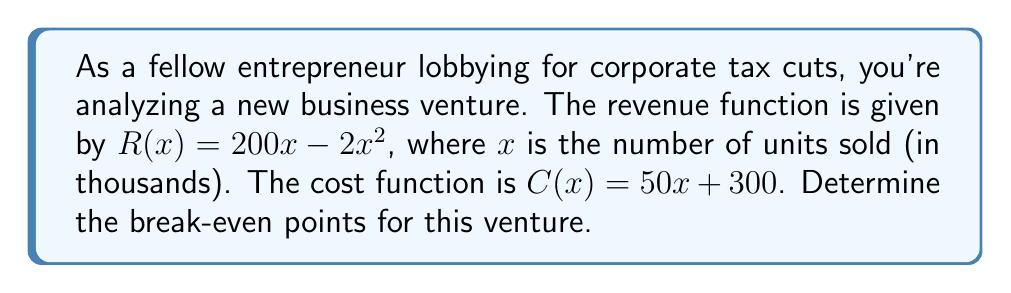Can you solve this math problem? To find the break-even points, we need to solve the equation where revenue equals cost:

1) Set up the equation:
   $R(x) = C(x)$
   $200x - 2x^2 = 50x + 300$

2) Rearrange to standard form:
   $-2x^2 + 150x - 300 = 0$

3) This is a quadratic equation. We can solve it using the quadratic formula:
   $x = \frac{-b \pm \sqrt{b^2 - 4ac}}{2a}$

   Where $a = -2$, $b = 150$, and $c = -300$

4) Substitute these values:
   $x = \frac{-150 \pm \sqrt{150^2 - 4(-2)(-300)}}{2(-2)}$

5) Simplify:
   $x = \frac{-150 \pm \sqrt{22500 - 2400}}{-4}$
   $x = \frac{-150 \pm \sqrt{20100}}{-4}$
   $x = \frac{-150 \pm 141.77}{-4}$

6) Solve for both possibilities:
   $x_1 = \frac{-150 + 141.77}{-4} = 2.06$
   $x_2 = \frac{-150 - 141.77}{-4} = 72.94$

7) Interpret the results:
   The break-even points occur at approximately 2,060 and 72,940 units.
Answer: 2,060 and 72,940 units 